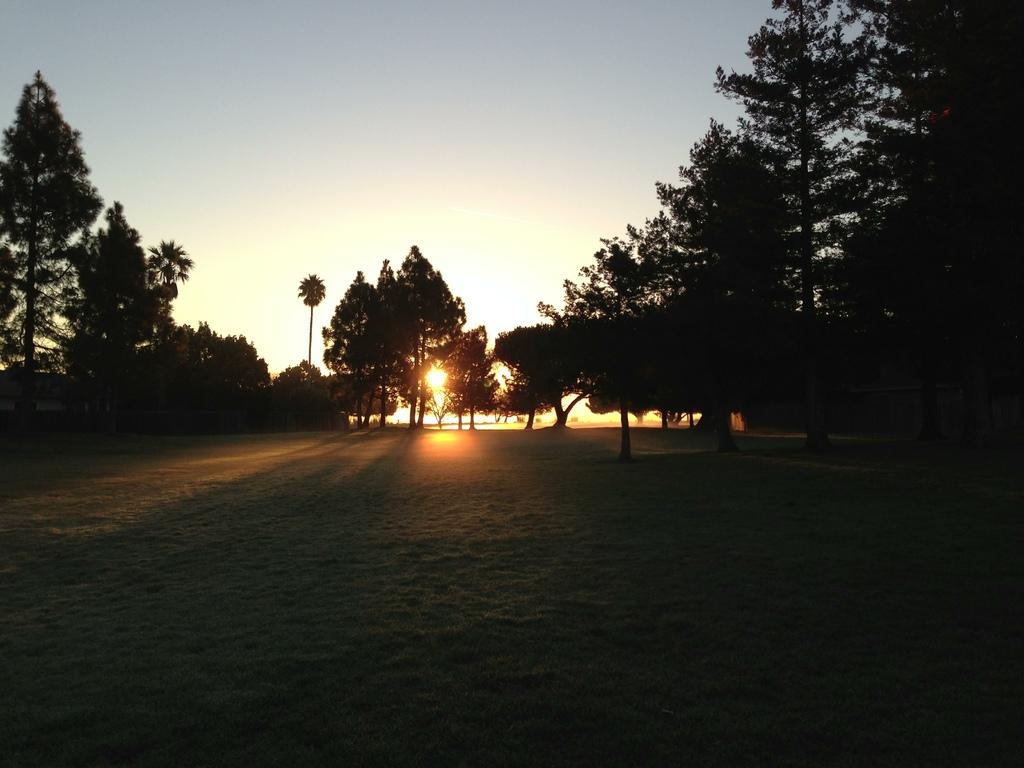What time of day was the image taken? The image was taken during sunset. What type of natural elements can be seen in the image? There are trees in the image. What is visible in the background of the image? There is sky visible in the image. Can the sun be seen in the image? Yes, the sun is observable in the image. What type of flowers are present in the image? There are no flowers visible in the image. What is the person wearing in the image? There is no person present in the image, so it is not possible to determine what they might be wearing. 